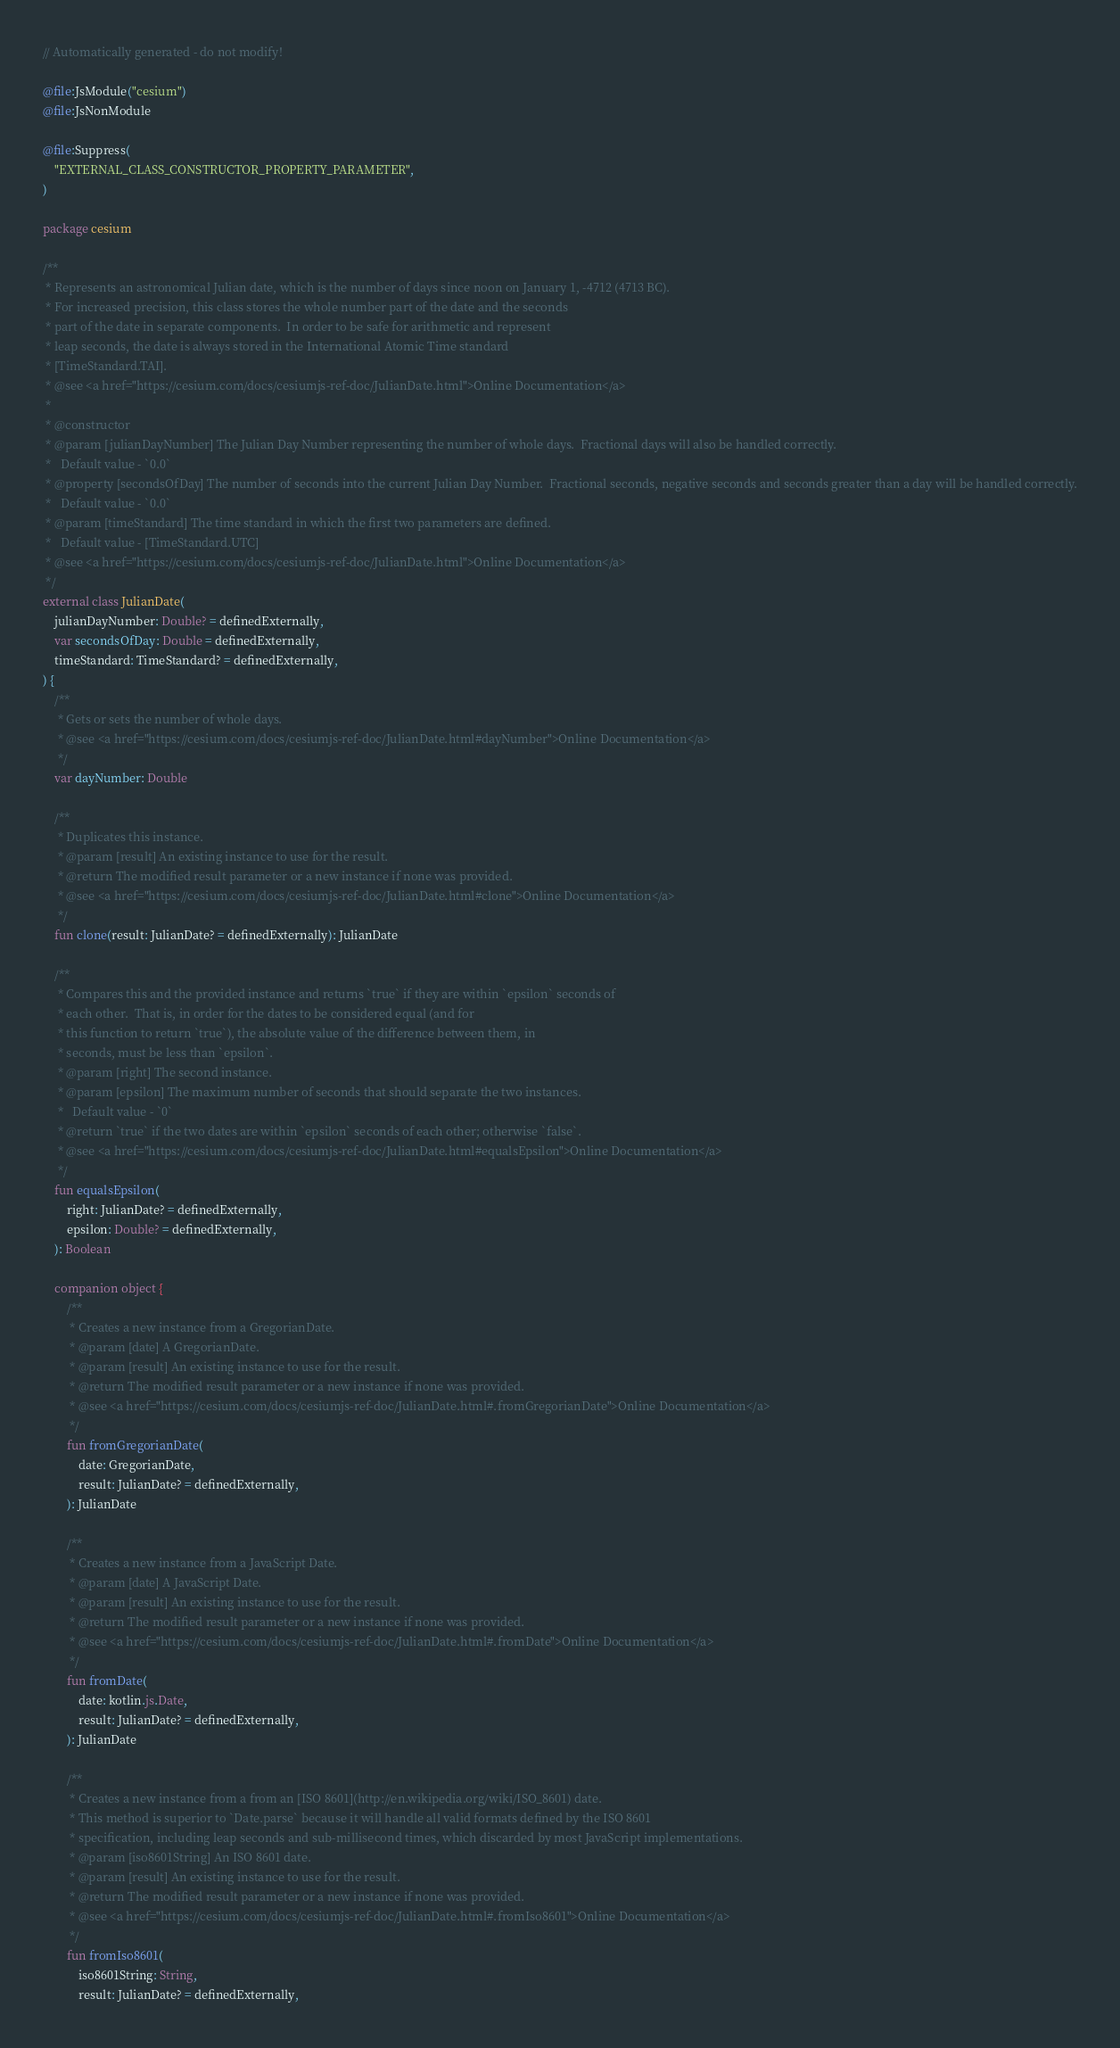<code> <loc_0><loc_0><loc_500><loc_500><_Kotlin_>// Automatically generated - do not modify!

@file:JsModule("cesium")
@file:JsNonModule

@file:Suppress(
    "EXTERNAL_CLASS_CONSTRUCTOR_PROPERTY_PARAMETER",
)

package cesium

/**
 * Represents an astronomical Julian date, which is the number of days since noon on January 1, -4712 (4713 BC).
 * For increased precision, this class stores the whole number part of the date and the seconds
 * part of the date in separate components.  In order to be safe for arithmetic and represent
 * leap seconds, the date is always stored in the International Atomic Time standard
 * [TimeStandard.TAI].
 * @see <a href="https://cesium.com/docs/cesiumjs-ref-doc/JulianDate.html">Online Documentation</a>
 *
 * @constructor
 * @param [julianDayNumber] The Julian Day Number representing the number of whole days.  Fractional days will also be handled correctly.
 *   Default value - `0.0`
 * @property [secondsOfDay] The number of seconds into the current Julian Day Number.  Fractional seconds, negative seconds and seconds greater than a day will be handled correctly.
 *   Default value - `0.0`
 * @param [timeStandard] The time standard in which the first two parameters are defined.
 *   Default value - [TimeStandard.UTC]
 * @see <a href="https://cesium.com/docs/cesiumjs-ref-doc/JulianDate.html">Online Documentation</a>
 */
external class JulianDate(
    julianDayNumber: Double? = definedExternally,
    var secondsOfDay: Double = definedExternally,
    timeStandard: TimeStandard? = definedExternally,
) {
    /**
     * Gets or sets the number of whole days.
     * @see <a href="https://cesium.com/docs/cesiumjs-ref-doc/JulianDate.html#dayNumber">Online Documentation</a>
     */
    var dayNumber: Double

    /**
     * Duplicates this instance.
     * @param [result] An existing instance to use for the result.
     * @return The modified result parameter or a new instance if none was provided.
     * @see <a href="https://cesium.com/docs/cesiumjs-ref-doc/JulianDate.html#clone">Online Documentation</a>
     */
    fun clone(result: JulianDate? = definedExternally): JulianDate

    /**
     * Compares this and the provided instance and returns `true` if they are within `epsilon` seconds of
     * each other.  That is, in order for the dates to be considered equal (and for
     * this function to return `true`), the absolute value of the difference between them, in
     * seconds, must be less than `epsilon`.
     * @param [right] The second instance.
     * @param [epsilon] The maximum number of seconds that should separate the two instances.
     *   Default value - `0`
     * @return `true` if the two dates are within `epsilon` seconds of each other; otherwise `false`.
     * @see <a href="https://cesium.com/docs/cesiumjs-ref-doc/JulianDate.html#equalsEpsilon">Online Documentation</a>
     */
    fun equalsEpsilon(
        right: JulianDate? = definedExternally,
        epsilon: Double? = definedExternally,
    ): Boolean

    companion object {
        /**
         * Creates a new instance from a GregorianDate.
         * @param [date] A GregorianDate.
         * @param [result] An existing instance to use for the result.
         * @return The modified result parameter or a new instance if none was provided.
         * @see <a href="https://cesium.com/docs/cesiumjs-ref-doc/JulianDate.html#.fromGregorianDate">Online Documentation</a>
         */
        fun fromGregorianDate(
            date: GregorianDate,
            result: JulianDate? = definedExternally,
        ): JulianDate

        /**
         * Creates a new instance from a JavaScript Date.
         * @param [date] A JavaScript Date.
         * @param [result] An existing instance to use for the result.
         * @return The modified result parameter or a new instance if none was provided.
         * @see <a href="https://cesium.com/docs/cesiumjs-ref-doc/JulianDate.html#.fromDate">Online Documentation</a>
         */
        fun fromDate(
            date: kotlin.js.Date,
            result: JulianDate? = definedExternally,
        ): JulianDate

        /**
         * Creates a new instance from a from an [ISO 8601](http://en.wikipedia.org/wiki/ISO_8601) date.
         * This method is superior to `Date.parse` because it will handle all valid formats defined by the ISO 8601
         * specification, including leap seconds and sub-millisecond times, which discarded by most JavaScript implementations.
         * @param [iso8601String] An ISO 8601 date.
         * @param [result] An existing instance to use for the result.
         * @return The modified result parameter or a new instance if none was provided.
         * @see <a href="https://cesium.com/docs/cesiumjs-ref-doc/JulianDate.html#.fromIso8601">Online Documentation</a>
         */
        fun fromIso8601(
            iso8601String: String,
            result: JulianDate? = definedExternally,</code> 